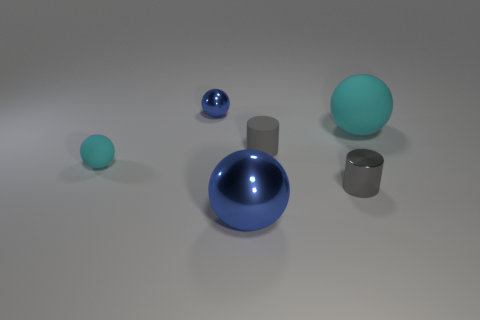Subtract all purple cylinders. How many blue spheres are left? 2 Subtract all big metal balls. How many balls are left? 3 Subtract 2 spheres. How many spheres are left? 2 Add 3 metal objects. How many objects exist? 9 Subtract all red balls. Subtract all yellow blocks. How many balls are left? 4 Subtract all cylinders. How many objects are left? 4 Subtract 1 cyan balls. How many objects are left? 5 Subtract all big cyan spheres. Subtract all small cyan things. How many objects are left? 4 Add 2 large metallic spheres. How many large metallic spheres are left? 3 Add 6 large blue objects. How many large blue objects exist? 7 